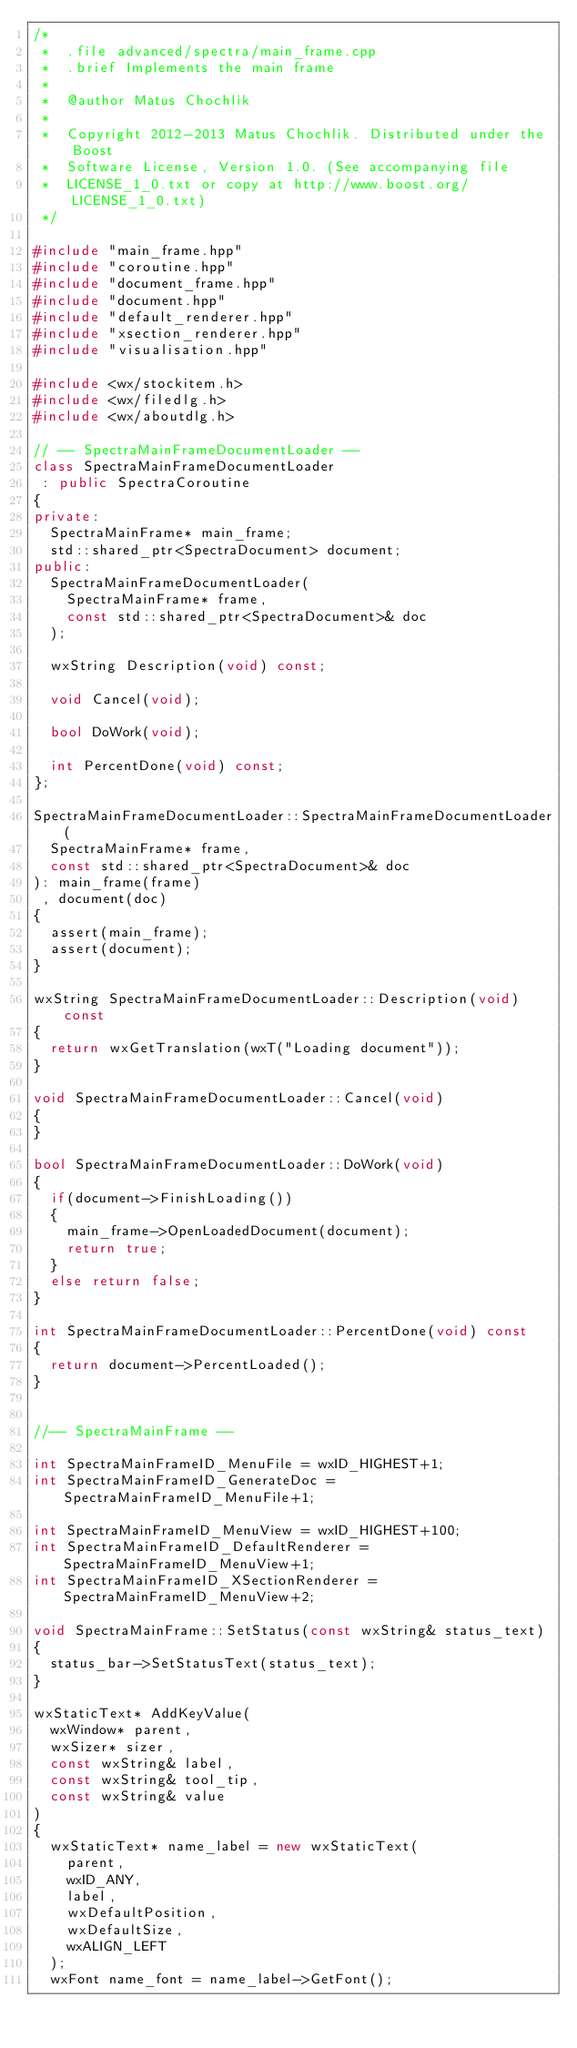<code> <loc_0><loc_0><loc_500><loc_500><_C++_>/*
 *  .file advanced/spectra/main_frame.cpp
 *  .brief Implements the main frame
 *
 *  @author Matus Chochlik
 *
 *  Copyright 2012-2013 Matus Chochlik. Distributed under the Boost
 *  Software License, Version 1.0. (See accompanying file
 *  LICENSE_1_0.txt or copy at http://www.boost.org/LICENSE_1_0.txt)
 */

#include "main_frame.hpp"
#include "coroutine.hpp"
#include "document_frame.hpp"
#include "document.hpp"
#include "default_renderer.hpp"
#include "xsection_renderer.hpp"
#include "visualisation.hpp"

#include <wx/stockitem.h>
#include <wx/filedlg.h>
#include <wx/aboutdlg.h>

// -- SpectraMainFrameDocumentLoader --
class SpectraMainFrameDocumentLoader
 : public SpectraCoroutine
{
private:
	SpectraMainFrame* main_frame;
	std::shared_ptr<SpectraDocument> document;
public:
	SpectraMainFrameDocumentLoader(
		SpectraMainFrame* frame,
		const std::shared_ptr<SpectraDocument>& doc
	);

	wxString Description(void) const;

	void Cancel(void);

	bool DoWork(void);

	int PercentDone(void) const;
};

SpectraMainFrameDocumentLoader::SpectraMainFrameDocumentLoader(
	SpectraMainFrame* frame,
	const std::shared_ptr<SpectraDocument>& doc
): main_frame(frame)
 , document(doc)
{
	assert(main_frame);
	assert(document);
}

wxString SpectraMainFrameDocumentLoader::Description(void) const
{
	return wxGetTranslation(wxT("Loading document"));
}

void SpectraMainFrameDocumentLoader::Cancel(void)
{
}

bool SpectraMainFrameDocumentLoader::DoWork(void)
{
	if(document->FinishLoading())
	{
		main_frame->OpenLoadedDocument(document);
		return true;
	}
	else return false;
}

int SpectraMainFrameDocumentLoader::PercentDone(void) const
{
	return document->PercentLoaded();
}


//-- SpectraMainFrame --

int SpectraMainFrameID_MenuFile = wxID_HIGHEST+1;
int SpectraMainFrameID_GenerateDoc = SpectraMainFrameID_MenuFile+1;

int SpectraMainFrameID_MenuView = wxID_HIGHEST+100;
int SpectraMainFrameID_DefaultRenderer = SpectraMainFrameID_MenuView+1;
int SpectraMainFrameID_XSectionRenderer = SpectraMainFrameID_MenuView+2;

void SpectraMainFrame::SetStatus(const wxString& status_text)
{
	status_bar->SetStatusText(status_text);
}

wxStaticText* AddKeyValue(
	wxWindow* parent,
	wxSizer* sizer,
	const wxString& label,
	const wxString& tool_tip,
	const wxString& value
)
{
	wxStaticText* name_label = new wxStaticText(
		parent,
		wxID_ANY,
		label,
		wxDefaultPosition,
		wxDefaultSize,
		wxALIGN_LEFT
	);
	wxFont name_font = name_label->GetFont();</code> 